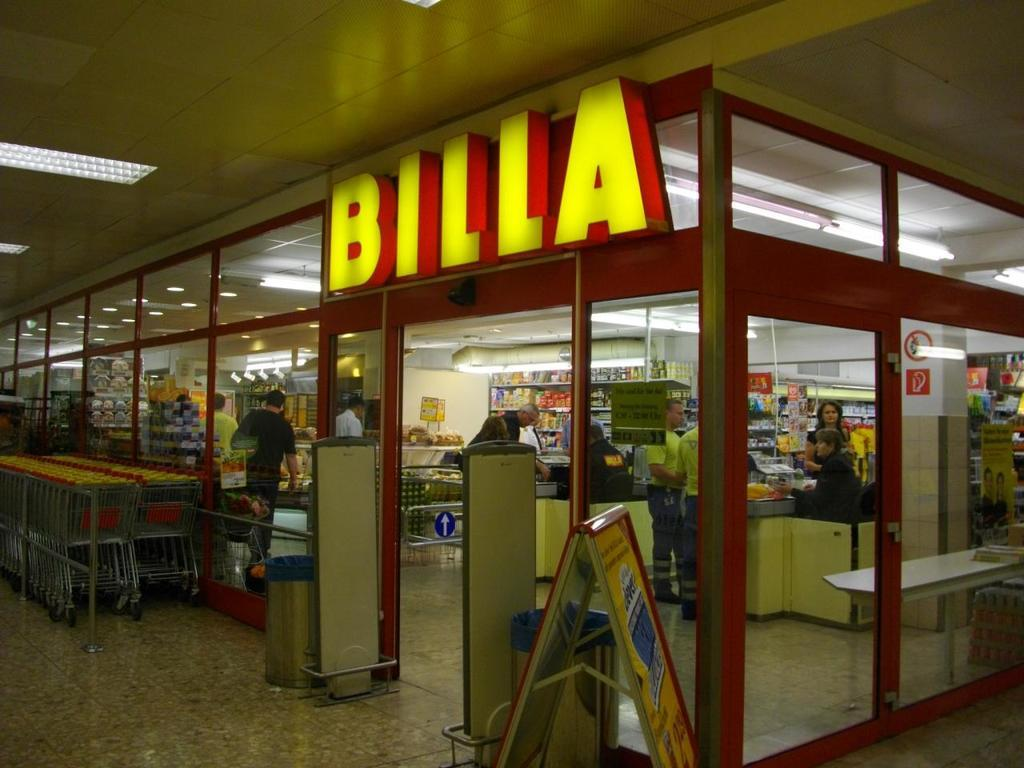Provide a one-sentence caption for the provided image. Shopping carts are available right outside the doors to Billa. 